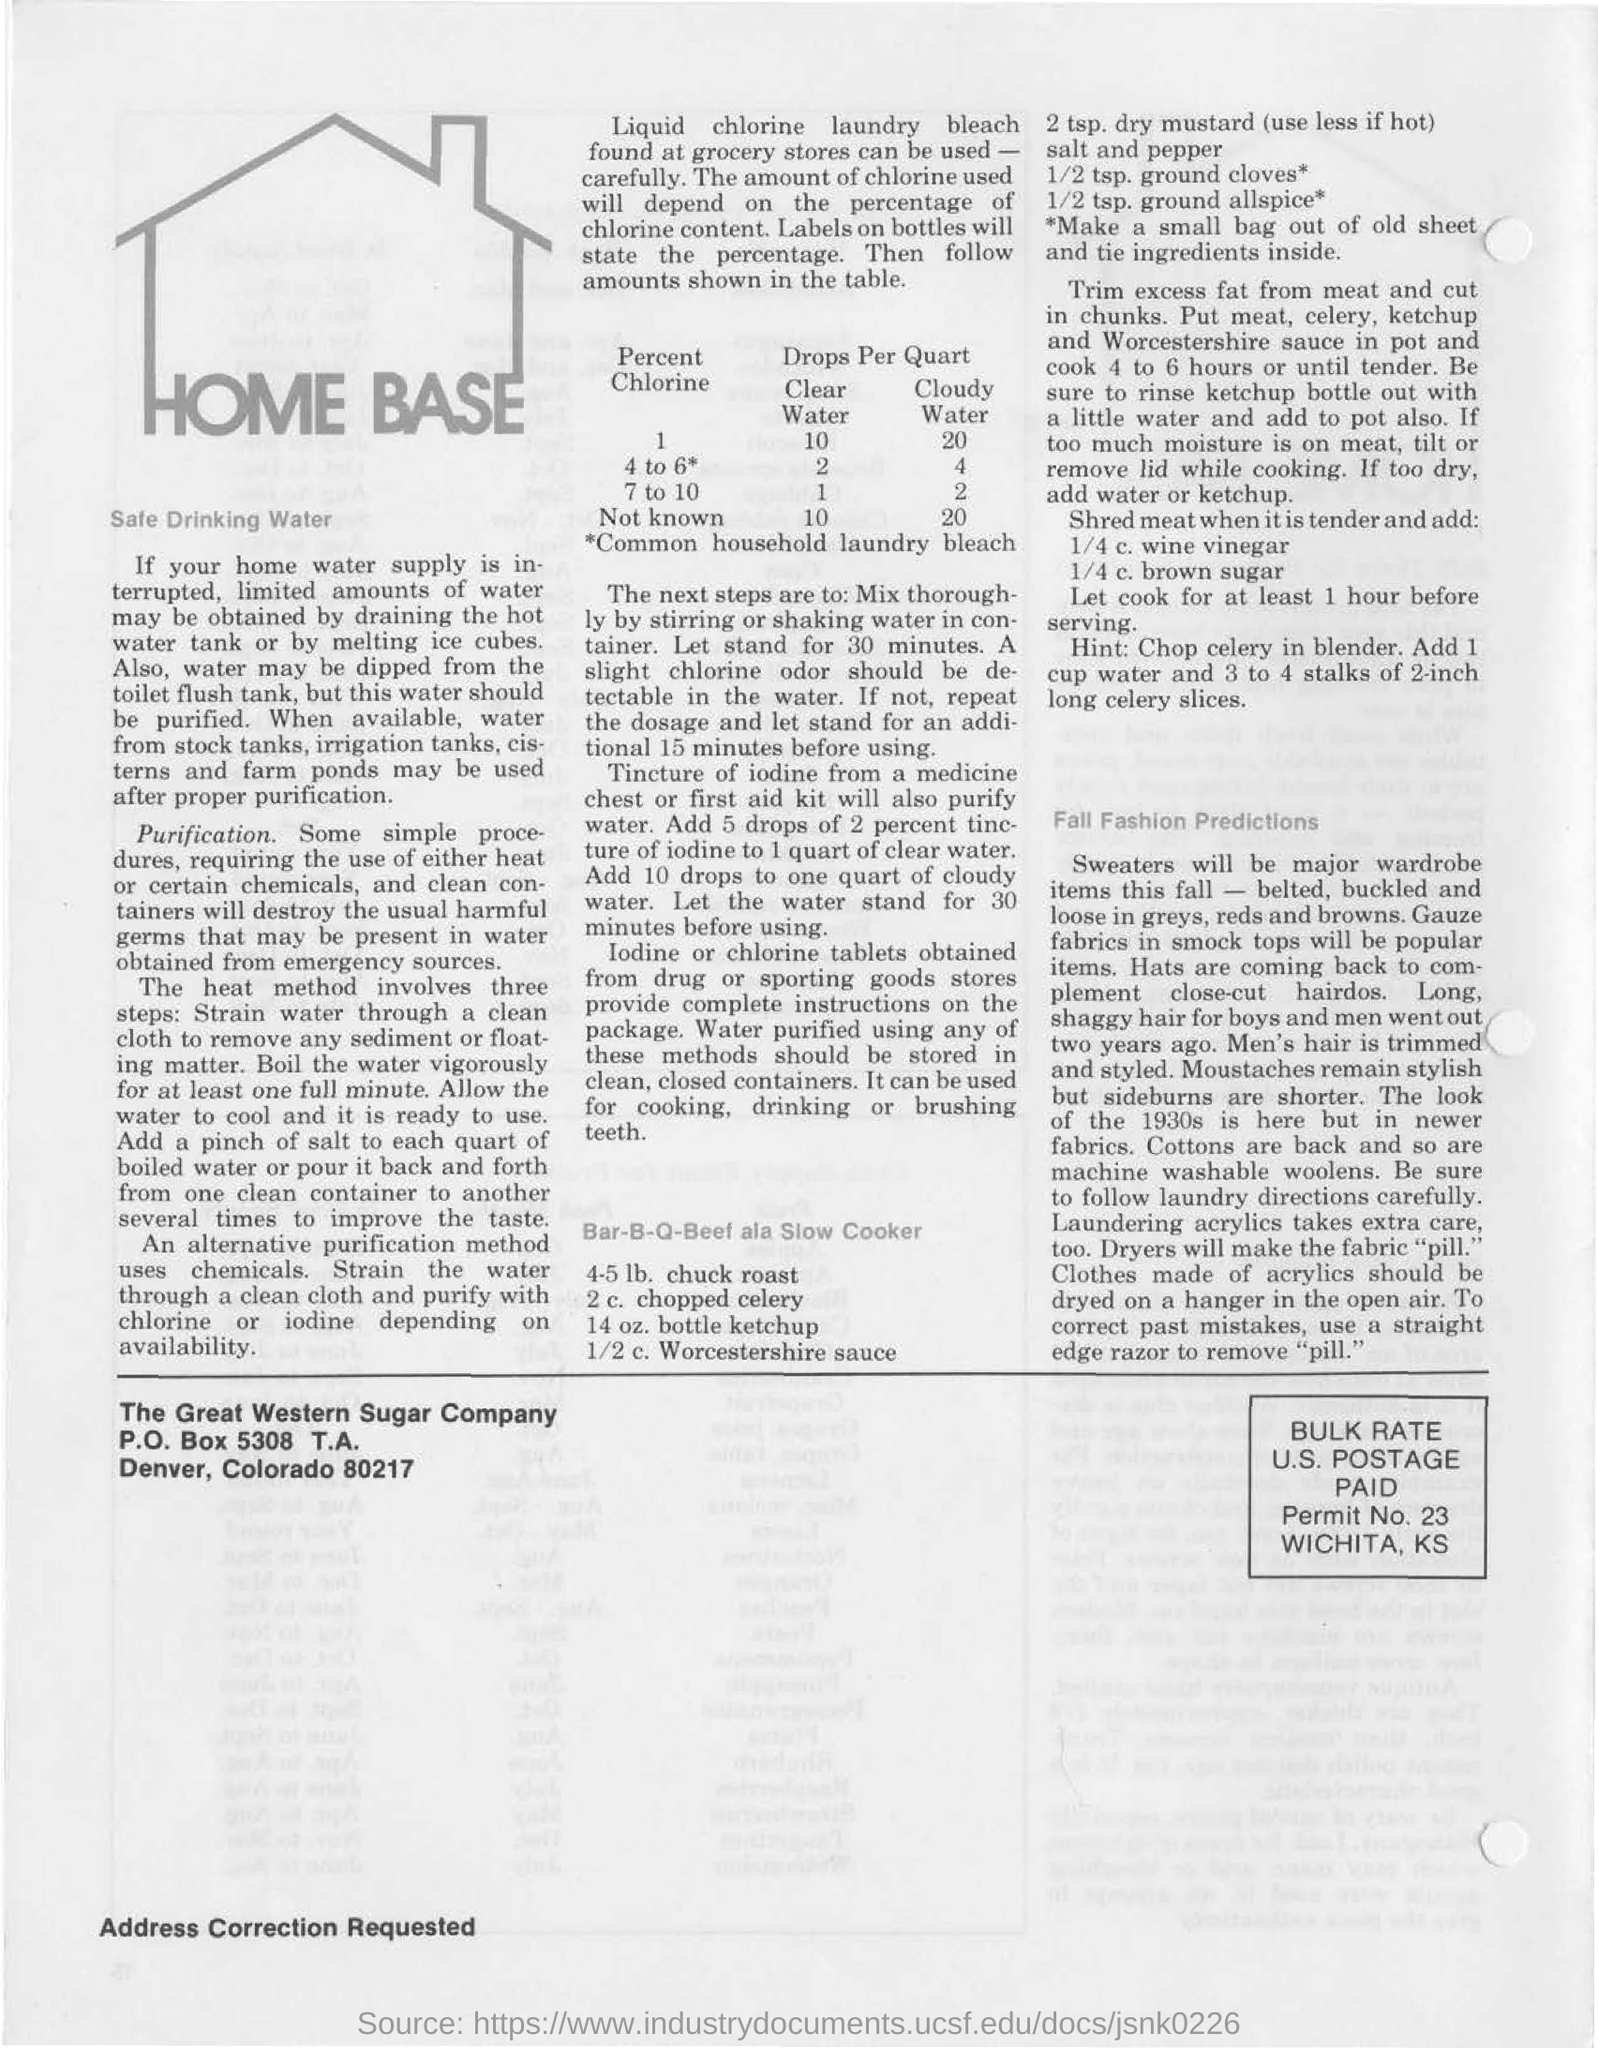Where can we obtain the water if home water supply is interrupted?
Your answer should be very brief. By draining the hot water tank or by melting ice cubes. What is the P.O.Box of The Great Western Sugar Company
Offer a very short reply. 5308. 